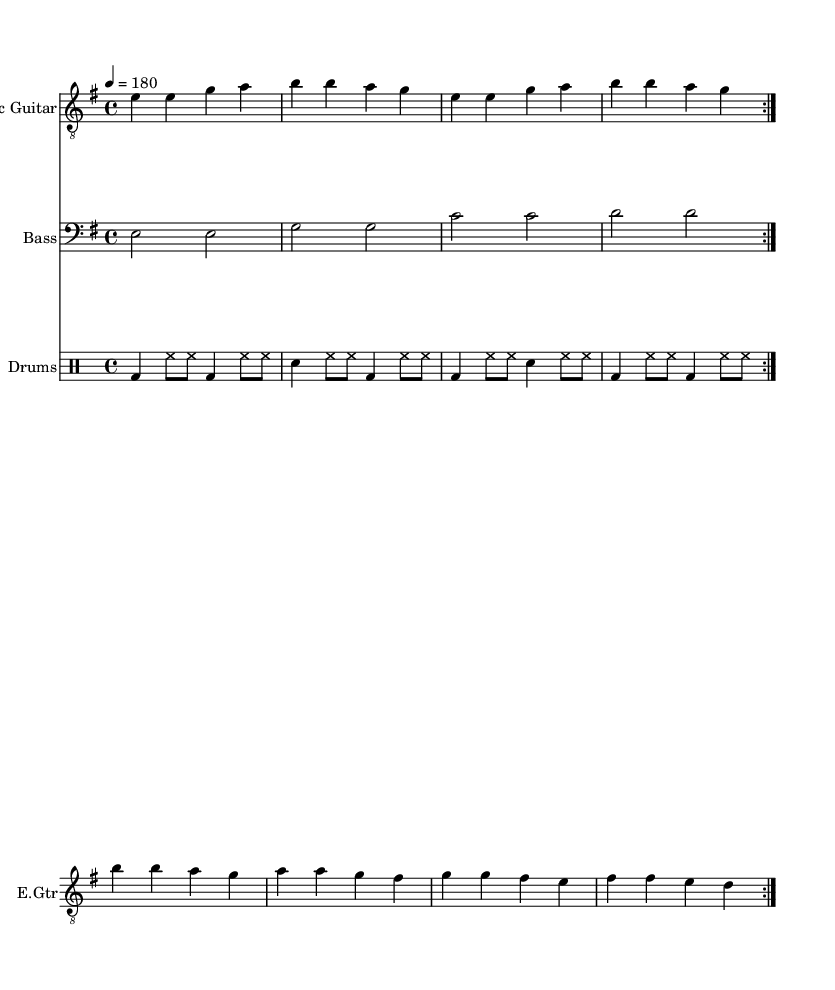What is the key signature of this music? The key signature is E minor, which has one sharp (F sharp). This is determined by the key signature shown at the beginning of the staff.
Answer: E minor What is the time signature of this music? The time signature is 4/4, indicated at the beginning of the score. This is read as four beats per measure, with a quarter note receiving one beat.
Answer: 4/4 What is the tempo marking in this piece? The tempo marking is 180 beats per minute, which is specified in the score as "4 = 180." This indicates how fast the piece should be played.
Answer: 180 How many measures are in the verse? The verse contains eight measures, which is evident from counting the measures in the provided melody lines for the lyrics.
Answer: 8 What is the main theme addressed in the lyrics? The main theme is the choice between social welfare and national security, as reflected in the contrasting lines about "guns and bread." This sets up the core conflict in the song.
Answer: social welfare vs. national security What instruments are featured in this piece? The piece features electric guitar, bass, and drums, as indicated by the individual staves labeled for each instrument in the score.
Answer: Electric guitar, bass, drums What is the repeated phrase in the chorus? The repeated phrase in the chorus is "What's it gonna be?" which emphasizes the central dilemma presented in the song. This can be noted as the chorus is clearly separated from the verse.
Answer: What's it gonna be? 